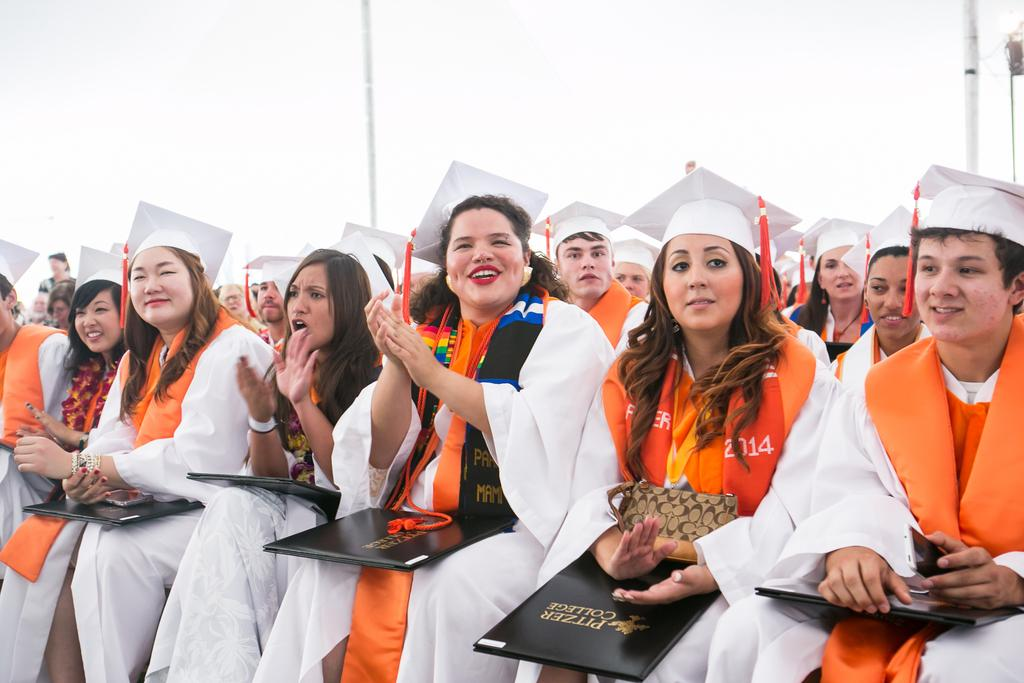What are the people in the image doing? People are seated in the image. What are the people wearing on their heads? The people are wearing white hats. What type of clothing are the people wearing? The people are wearing graduation dresses. What colors are the graduation dresses? The graduation dresses are white and orange. What are the people holding in their hands? The people are holding files. What can be seen at the back of the scene? There are poles at the back of the scene. How many dogs are present in the image? There are no dogs present in the image. What type of body is visible in the image? There is no specific body visible in the image; it features people seated in graduation dresses. 